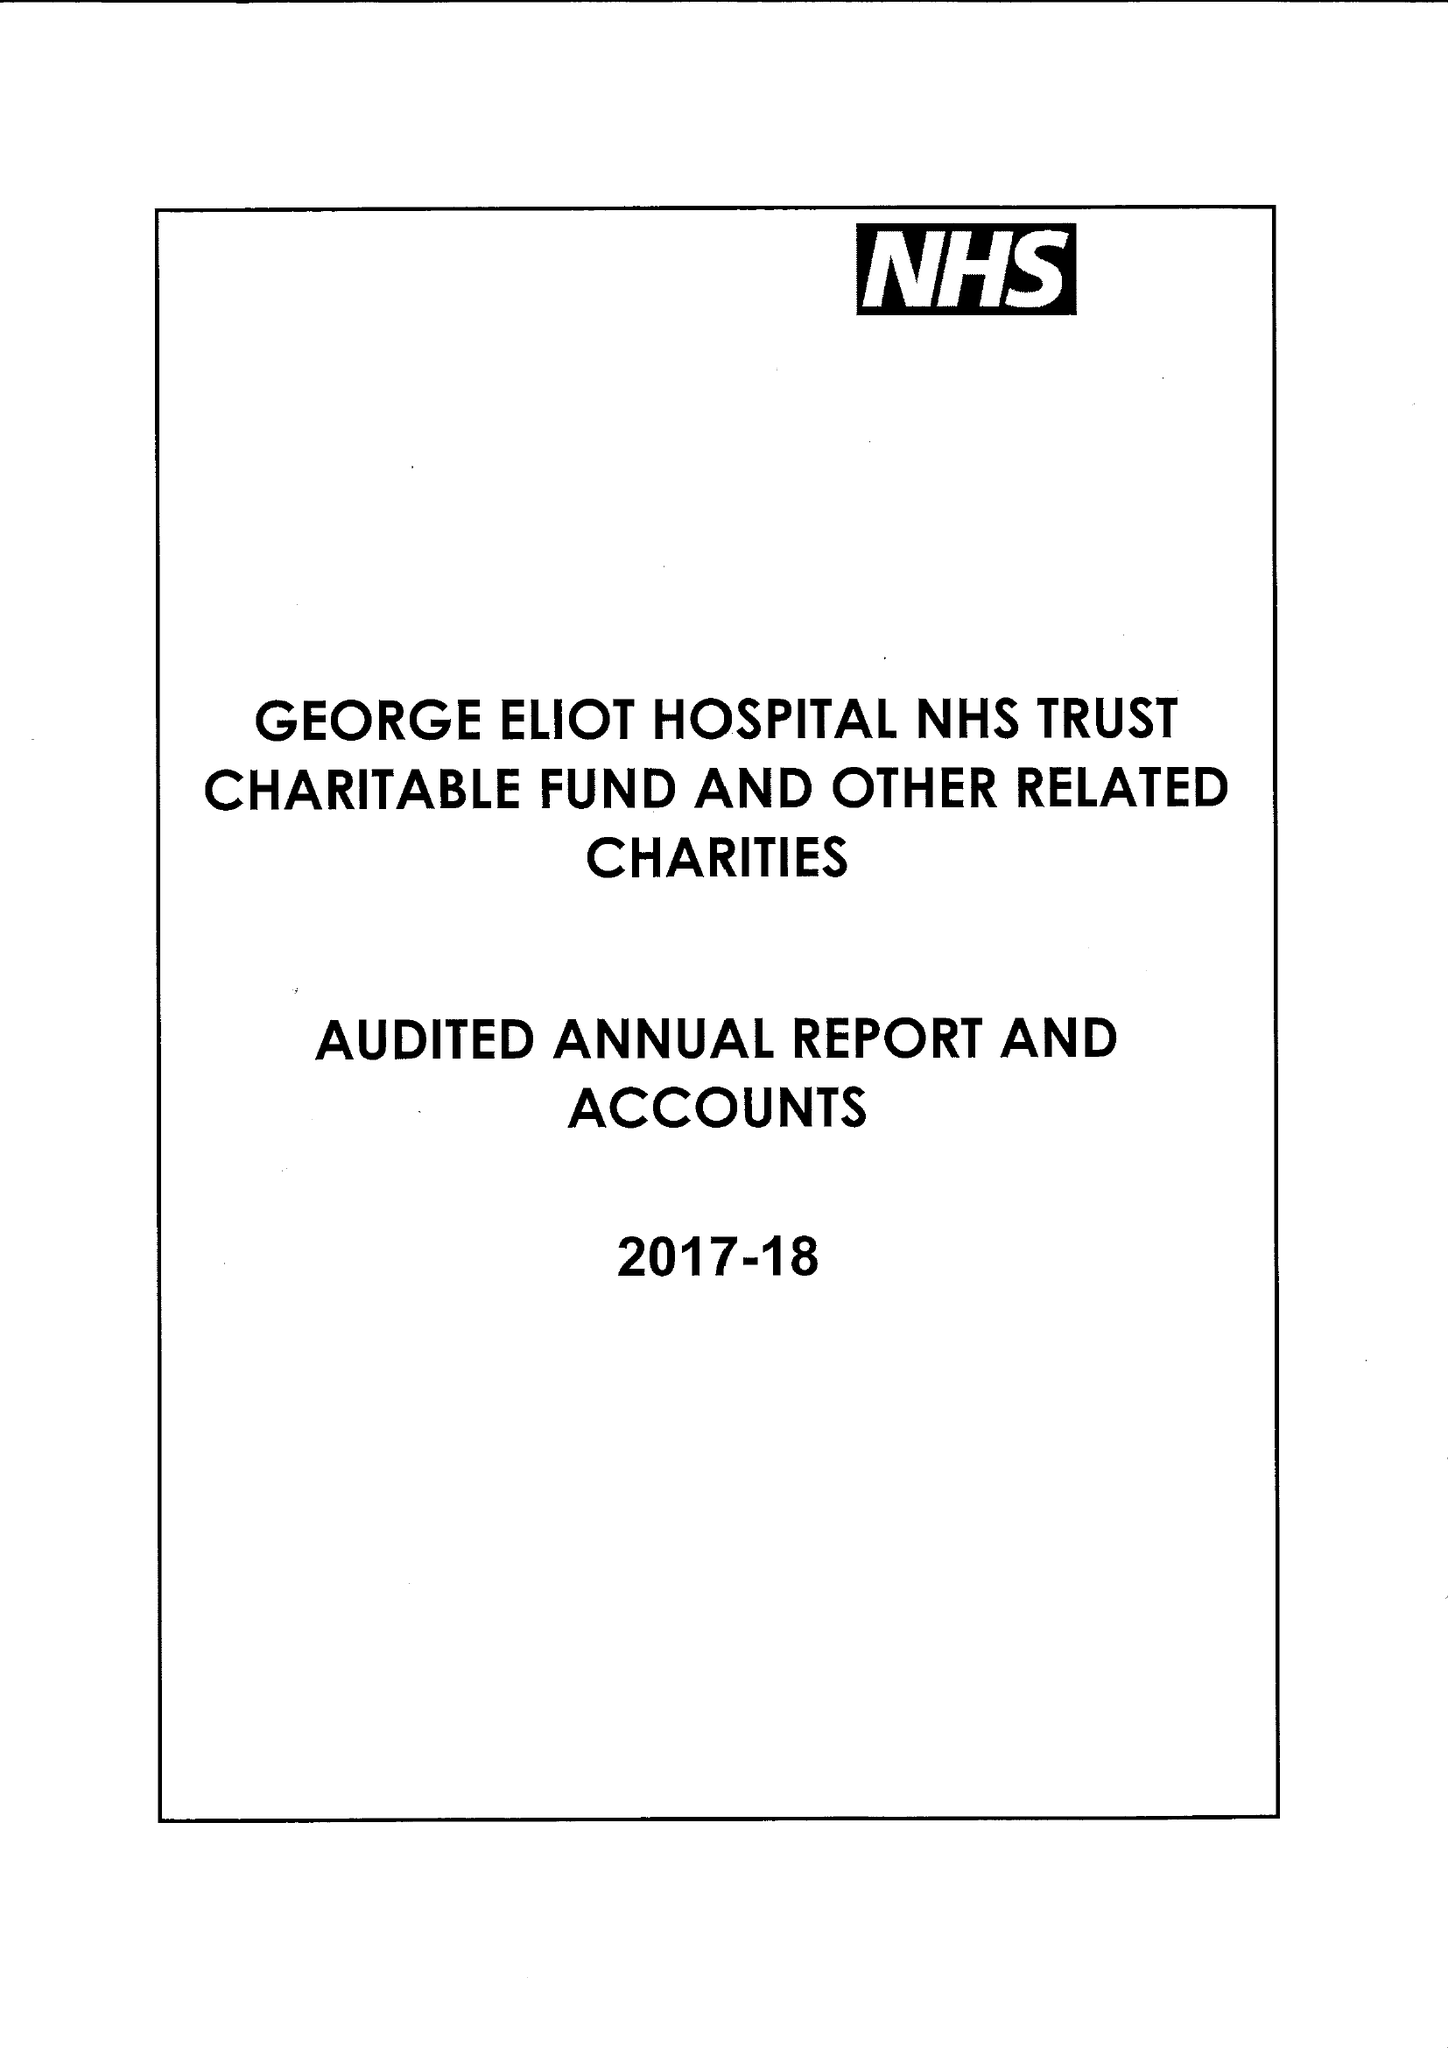What is the value for the charity_name?
Answer the question using a single word or phrase. George Eliot Hospital Nhs Trust Charitable Fund and Other Related Charities 